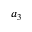<formula> <loc_0><loc_0><loc_500><loc_500>a _ { 3 }</formula> 